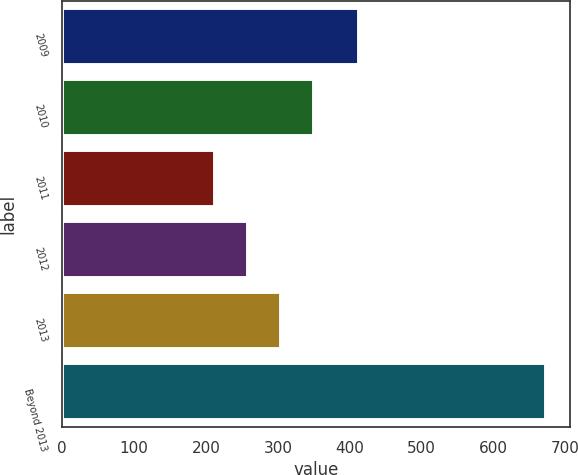Convert chart. <chart><loc_0><loc_0><loc_500><loc_500><bar_chart><fcel>2009<fcel>2010<fcel>2011<fcel>2012<fcel>2013<fcel>Beyond 2013<nl><fcel>413<fcel>350.3<fcel>212<fcel>258.1<fcel>304.2<fcel>673<nl></chart> 